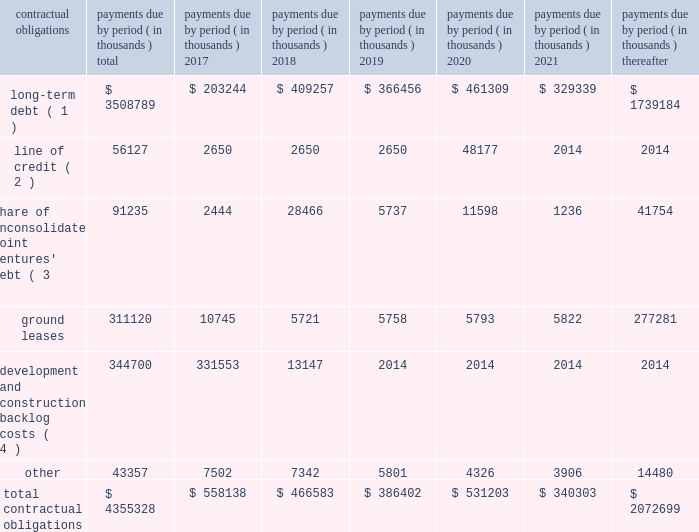
( 1 ) our long-term debt consists of both secured and unsecured debt and includes both principal and interest .
Interest payments for variable rate debt were calculated using the interest rates as of december 31 , 2016 .
Repayment of our $ 250.0 million variable rate term note , which has a contractual maturity date in january 2019 , is reflected as a 2020 obligation in the table above based on the ability to exercise a one-year extension , which we may exercise at our discretion .
( 2 ) our unsecured line of credit has a contractual maturity date in january 2019 , but is reflected as a 2020 obligation in the table above based on the ability to exercise a one-year extension , which we may exercise at our discretion .
Interest payments for our unsecured line of credit were calculated using the most recent stated interest rate that was in effect.ff ( 3 ) our share of unconsolidated joint venture debt includes both principal and interest .
Interest expense for variable rate debt was calculated using the interest rate at december 31 , 2016 .
( 4 ) represents estimated remaining costs on the completion of owned development projects and third-party construction projects .
Related party y transactionstt we provide property and asset management , leasing , construction and other tenant-related services to ww unconsolidated companies in which we have equity interests .
For the years ended december 31 , 2016 , 2015 and 2014 we earned management fees of $ 4.5 million , $ 6.8 million and $ 8.5 million , leasing fees of $ 2.4 million , $ 3.0 million and $ 3.4 million and construction and development fees of $ 8.0 million , $ 6.1 million and $ 5.8 million , respectively , from these companies , prior to elimination of our ownership percentage .
Yy we recorded these fees based ww on contractual terms that approximate market rates for these types of services and have eliminated our ownership percentages of these fees in the consolidated financial statements .
Commitments and contingenciesg the partnership has guaranteed the repayment of $ 32.9 million of economic development bonds issued by various municipalities in connection with certain commercial developments .
We will be required to make payments under ww our guarantees to the extent that incremental taxes from specified developments are not sufficient to pay the bond ff debt service .
Management does not believe that it is probable that we will be required to make any significant payments in satisfaction of these guarantees .
The partnership also has guaranteed the repayment of an unsecured loan of one of our unconsolidated subsidiaries .
At december 31 , 2016 , the maximum guarantee exposure for this loan was approximately $ 52.1 million .
We lease certain land positions with terms extending toww march 2114 , with a total future payment obligation of $ 311.1 million .
The payments on these ground leases , which are classified as operating leases , are not material in any individual year .
In addition to ground leases , we are party to other operating leases as part of conducting our business , including leases of office space from third parties , with a total future payment obligation of ff $ 43.4 million at december 31 , 2016 .
No future payments on these leases are material in any individual year .
We are subject to various legal proceedings and claims that arise in the ordinary course of business .
In the opinion ww of management , the amount of any ultimate liability with respect to these actions is not expected to materially affect ff our consolidated financial statements or results of operations .
We own certain parcels of land that are subject to special property tax assessments levied by quasi municipalww entities .
To the extent that such special assessments are fixed and determinable , the discounted value of the fulltt .
What was the total fees earned in 2016 for management , leasing and construction and development? 
Computations: (8.0 + (4.5 + 2.4))
Answer: 14.9. 